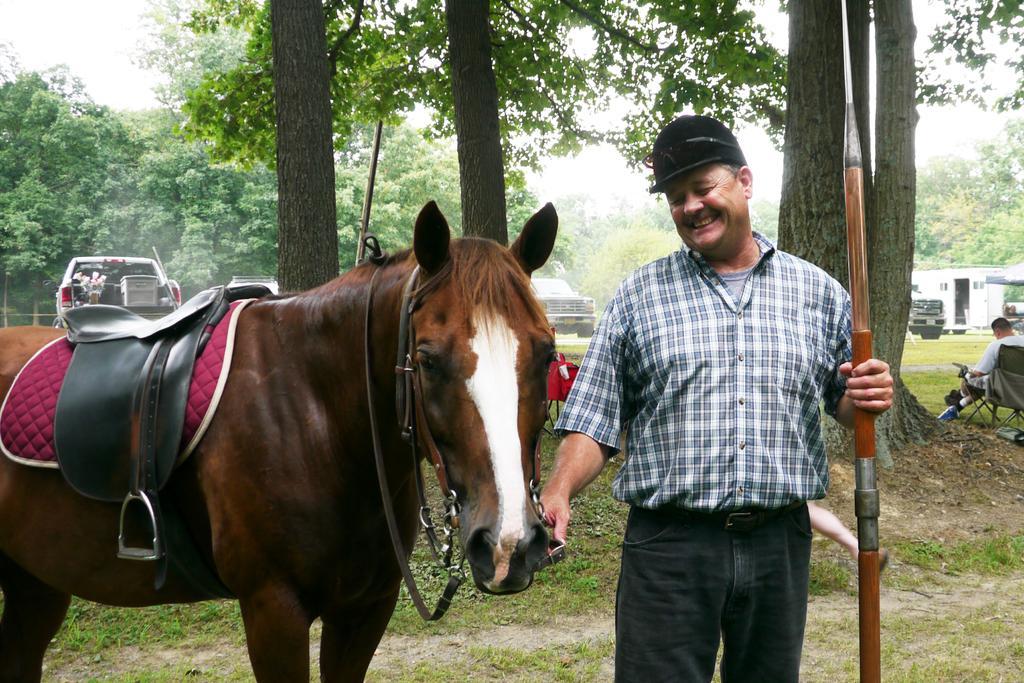How would you summarize this image in a sentence or two? In this image there is a person who is wearing white color shirt catching horse in his right hand and holding something in his left hand and at the background of the image there are trees and cars. 